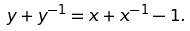Convert formula to latex. <formula><loc_0><loc_0><loc_500><loc_500>y + y ^ { - 1 } = x + x ^ { - 1 } - 1 .</formula> 